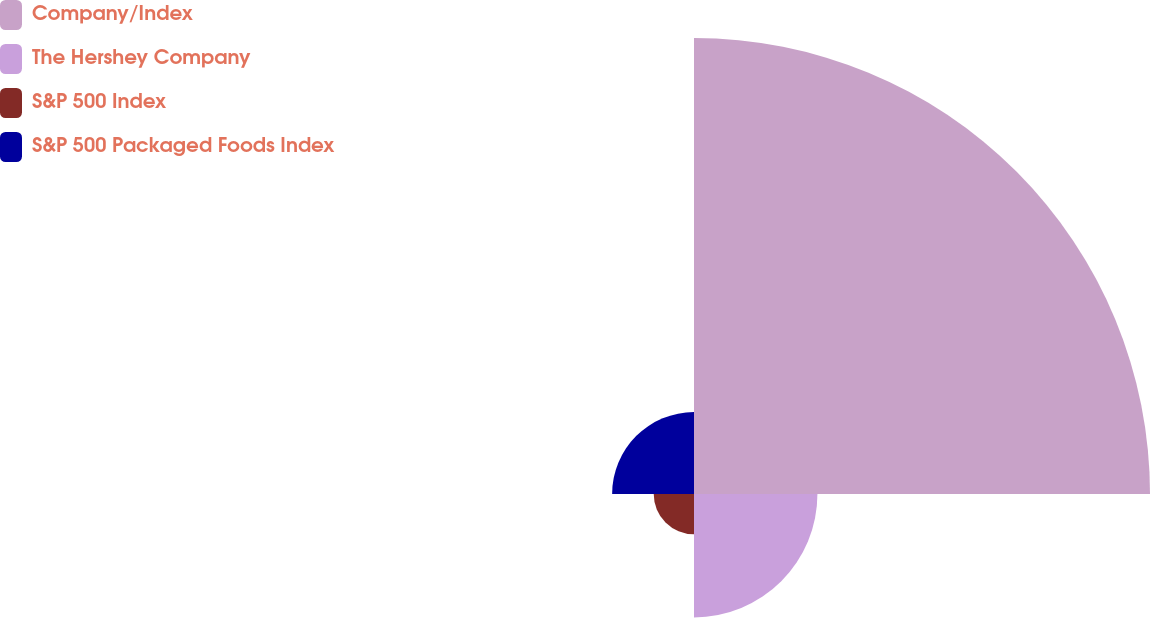Convert chart. <chart><loc_0><loc_0><loc_500><loc_500><pie_chart><fcel>Company/Index<fcel>The Hershey Company<fcel>S&P 500 Index<fcel>S&P 500 Packaged Foods Index<nl><fcel>64.99%<fcel>17.59%<fcel>5.74%<fcel>11.67%<nl></chart> 